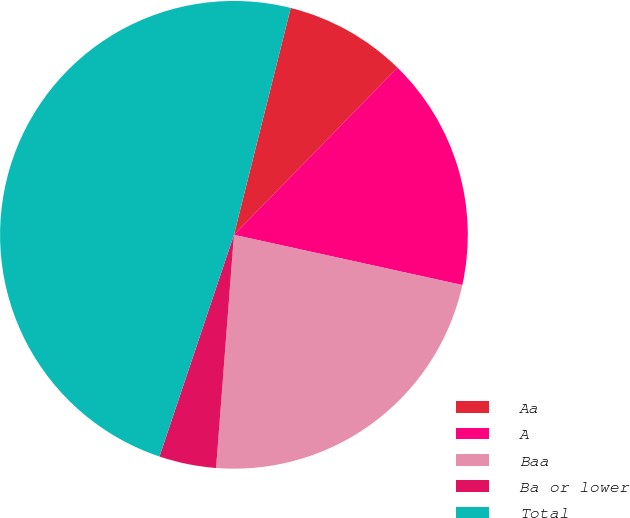Convert chart to OTSL. <chart><loc_0><loc_0><loc_500><loc_500><pie_chart><fcel>Aa<fcel>A<fcel>Baa<fcel>Ba or lower<fcel>Total<nl><fcel>8.42%<fcel>16.12%<fcel>22.77%<fcel>3.94%<fcel>48.74%<nl></chart> 